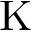Convert formula to latex. <formula><loc_0><loc_0><loc_500><loc_500>K</formula> 